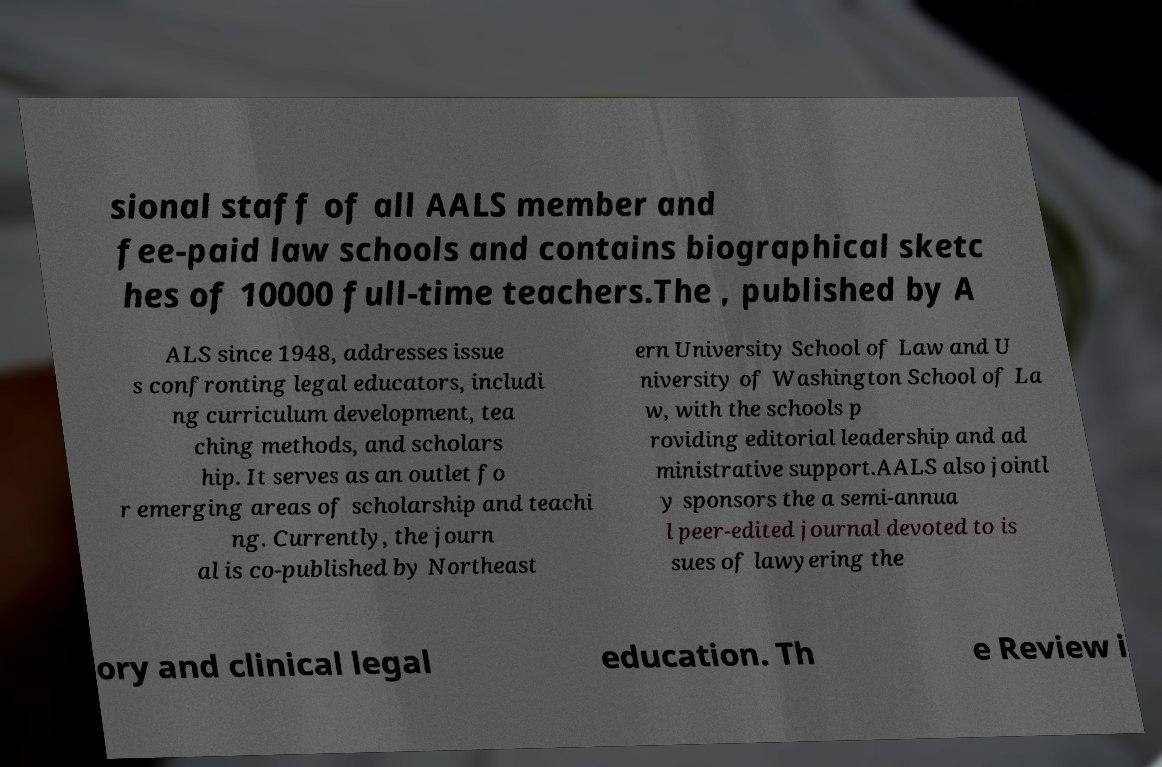There's text embedded in this image that I need extracted. Can you transcribe it verbatim? sional staff of all AALS member and fee-paid law schools and contains biographical sketc hes of 10000 full-time teachers.The , published by A ALS since 1948, addresses issue s confronting legal educators, includi ng curriculum development, tea ching methods, and scholars hip. It serves as an outlet fo r emerging areas of scholarship and teachi ng. Currently, the journ al is co-published by Northeast ern University School of Law and U niversity of Washington School of La w, with the schools p roviding editorial leadership and ad ministrative support.AALS also jointl y sponsors the a semi-annua l peer-edited journal devoted to is sues of lawyering the ory and clinical legal education. Th e Review i 